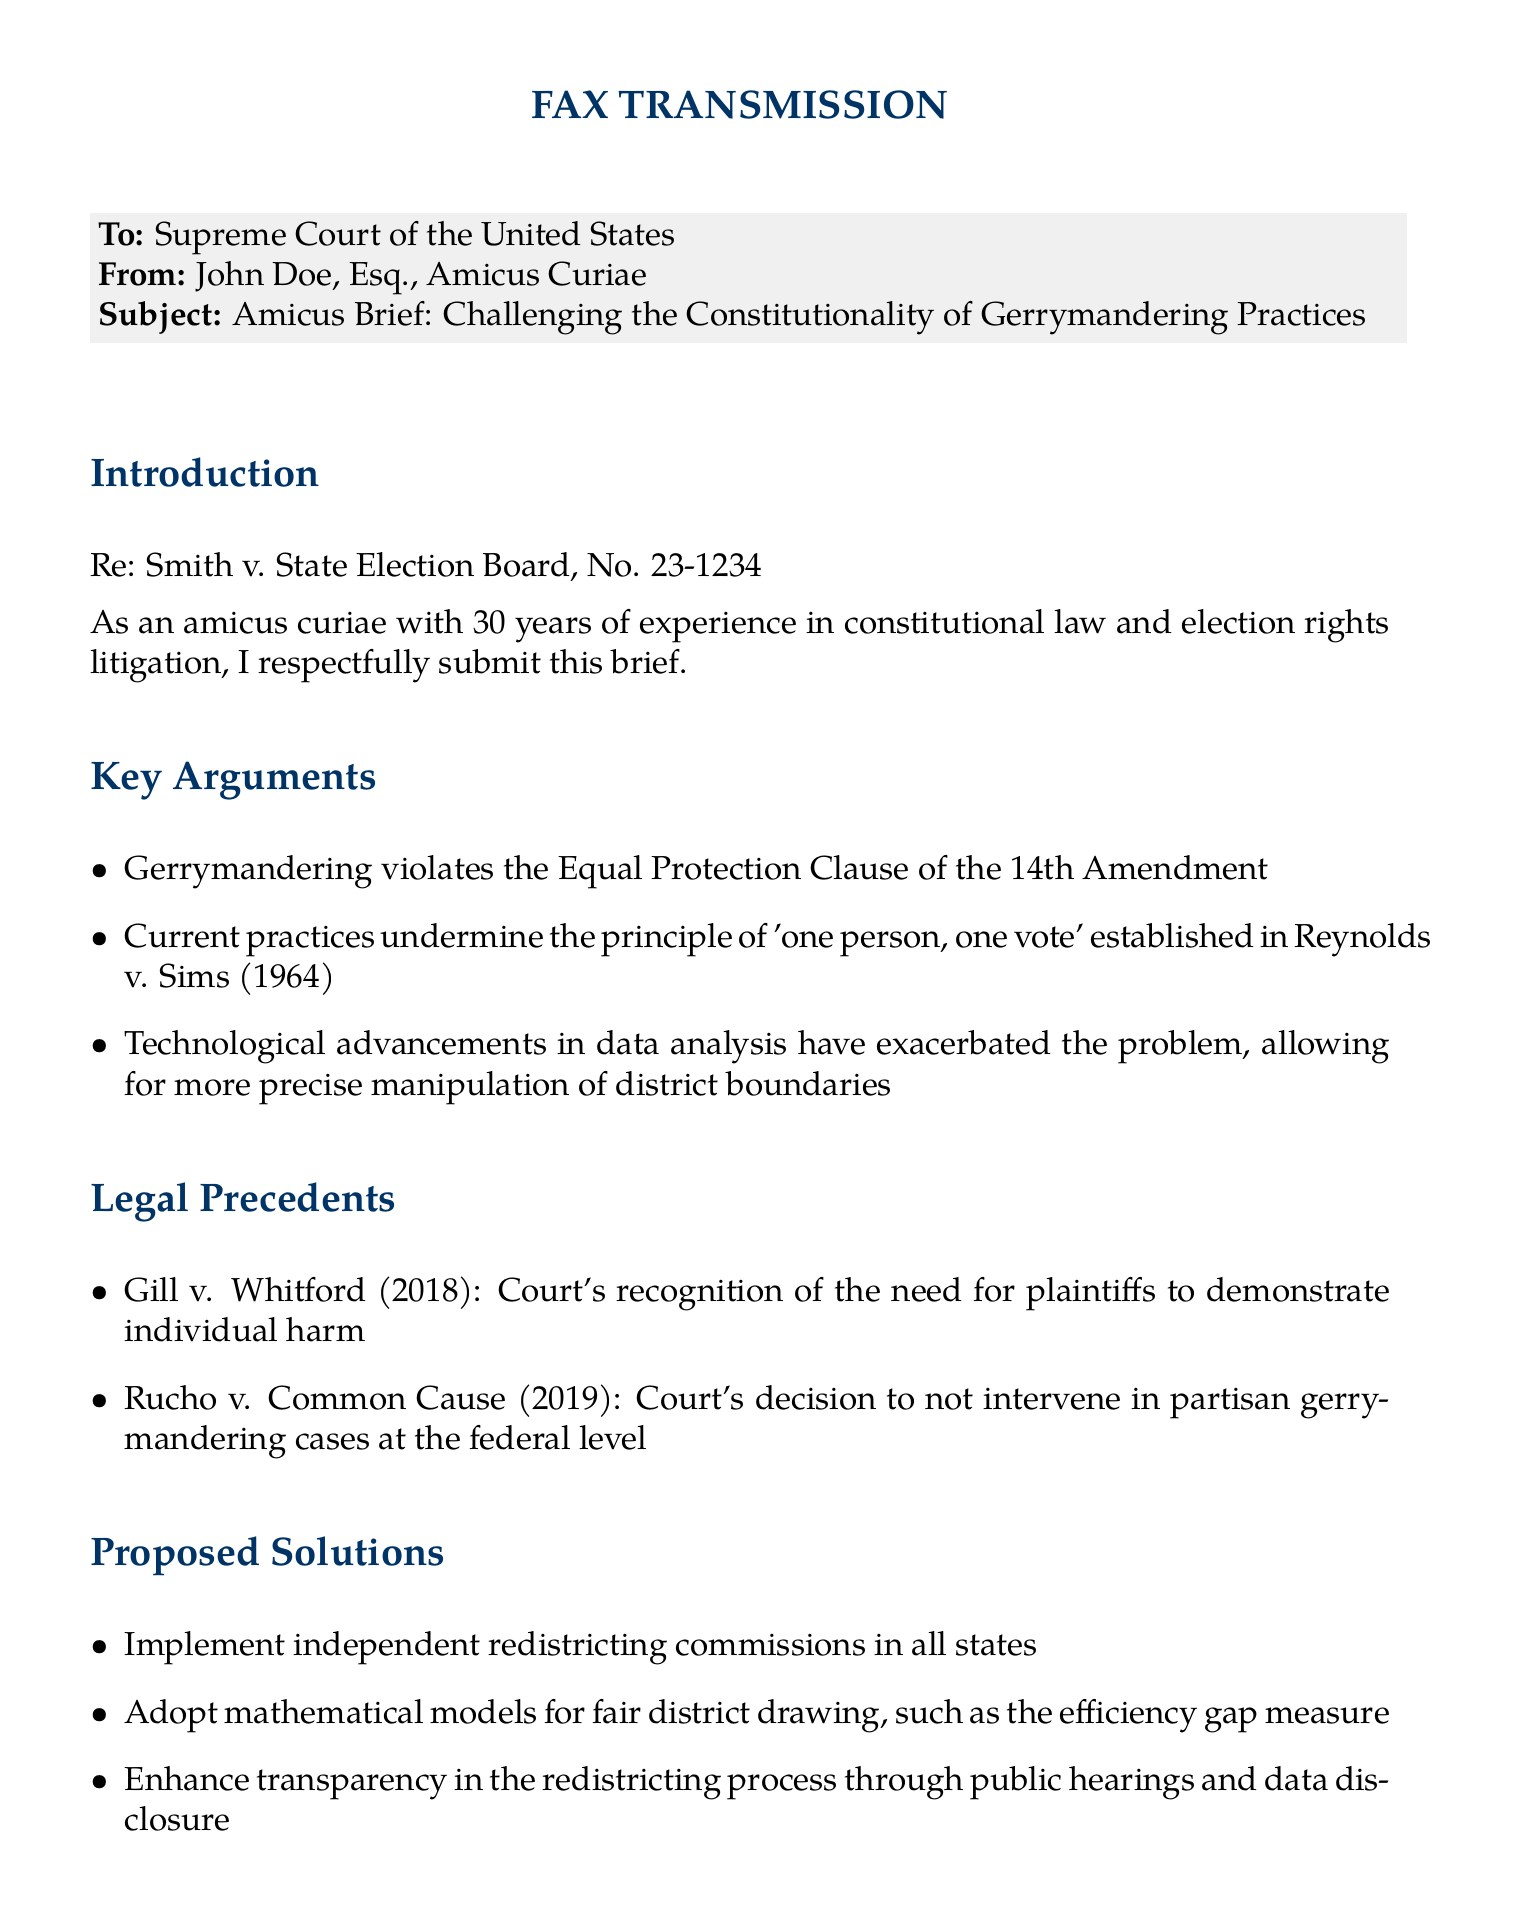What is the case name referenced in the brief? The case name mentioned in the brief is related to the legal document.
Answer: Smith v. State Election Board Who is the amicus curiae submitting the brief? The brief identifies the individual responsible for submitting it.
Answer: John Doe What is the main constitutional issue addressed in the brief? The brief outlines the primary legal concern regarding electoral practices.
Answer: Gerrymandering In which year was the Reynolds v. Sims case decided? Historical context regarding a key precedent is provided.
Answer: 1964 Which Supreme Court case recognized the need for plaintiffs to demonstrate individual harm? The document lists relevant legal precedents that support its arguments.
Answer: Gill v. Whitford What type of reform does the brief propose for redistricting? The brief suggests a specific mechanism to enhance the fairness of districting.
Answer: Independent redistricting commissions Which mathematical model is mentioned as a solution in the brief? The brief mentions statistical methods for improving electoral fairness.
Answer: Efficiency gap measure What specific action does the author urge the Court to take? The conclusion of the document emphasizes a particular judicial action.
Answer: Establish clear, manageable standards What potential outcome does the author believe this action could have? The brief concludes with a hope for an important societal benefit.
Answer: Safeguard the integrity of democratic representation 